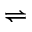<formula> <loc_0><loc_0><loc_500><loc_500>\rightleftharpoons</formula> 